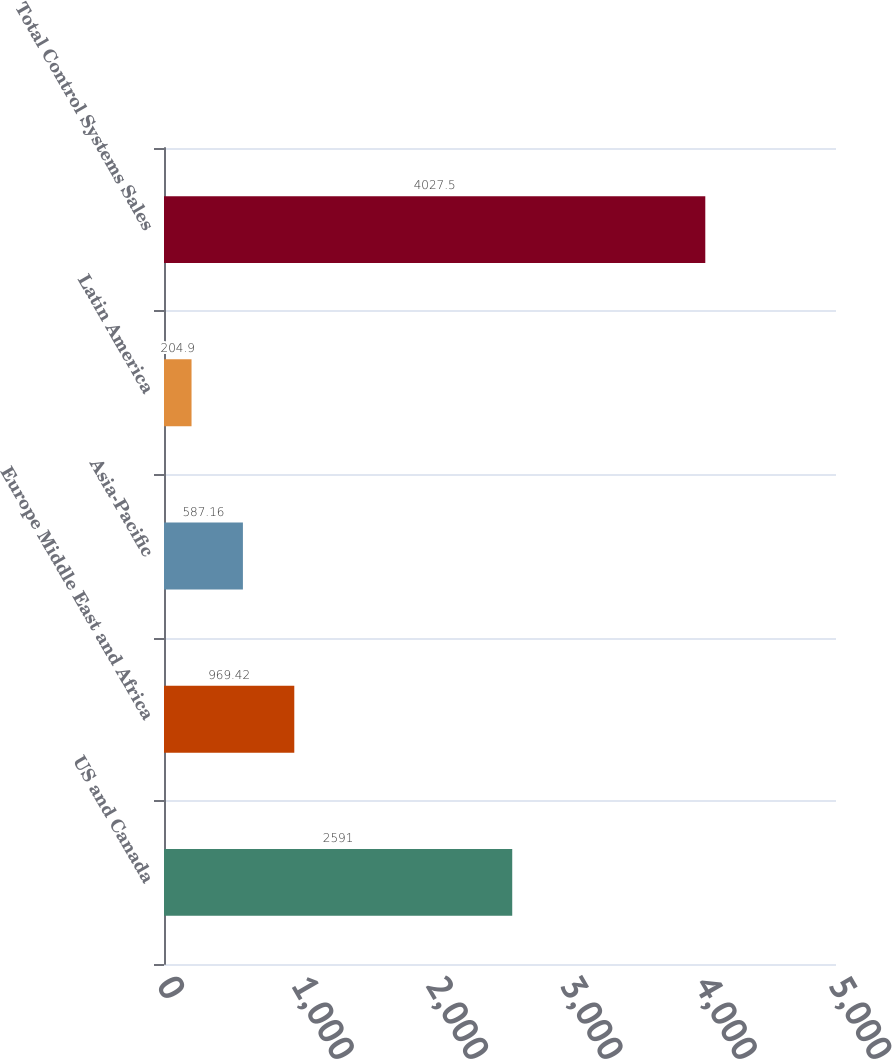Convert chart. <chart><loc_0><loc_0><loc_500><loc_500><bar_chart><fcel>US and Canada<fcel>Europe Middle East and Africa<fcel>Asia-Pacific<fcel>Latin America<fcel>Total Control Systems Sales<nl><fcel>2591<fcel>969.42<fcel>587.16<fcel>204.9<fcel>4027.5<nl></chart> 